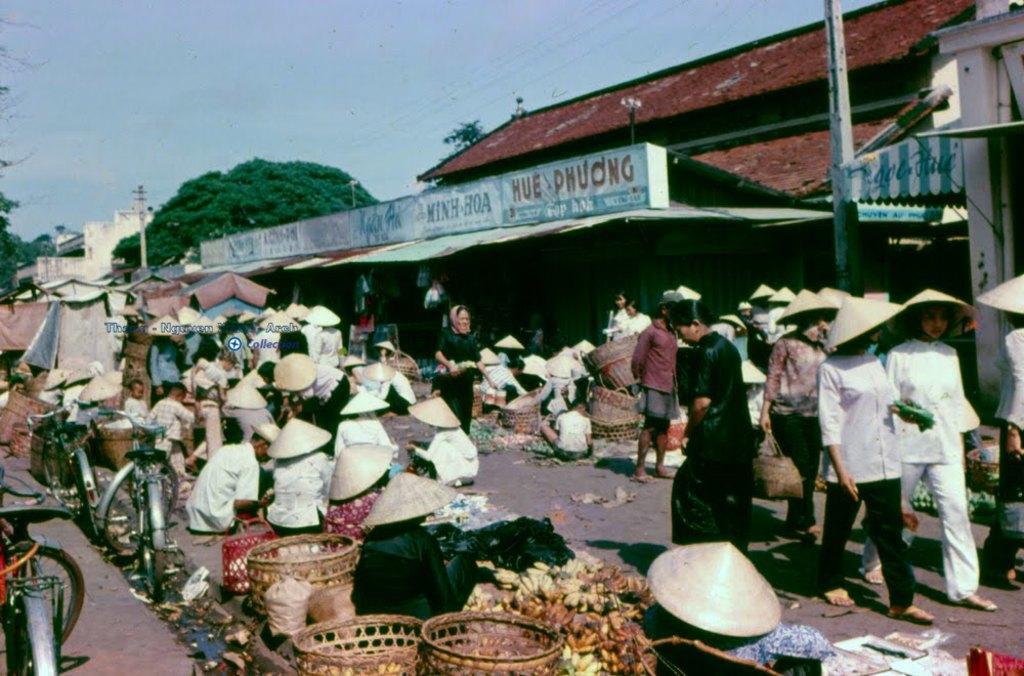How would you summarize this image in a sentence or two? This image look like it has been taken in a market, where a group of people are wearing caps and selling food items and a few among them are carrying objects and walking, in front of them there are poles, houses with has some text written on the boards, on the bottom left corner of the image there are bicycles, and in the background there are houses, trees and a pole. 